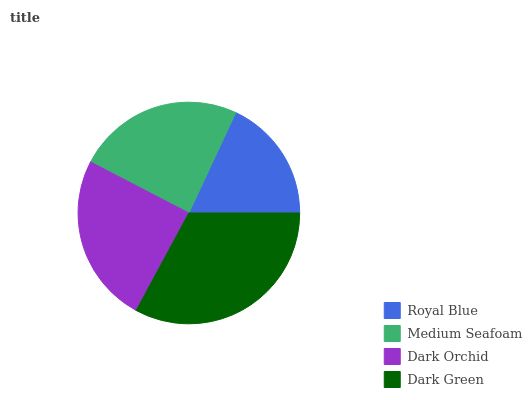Is Royal Blue the minimum?
Answer yes or no. Yes. Is Dark Green the maximum?
Answer yes or no. Yes. Is Medium Seafoam the minimum?
Answer yes or no. No. Is Medium Seafoam the maximum?
Answer yes or no. No. Is Medium Seafoam greater than Royal Blue?
Answer yes or no. Yes. Is Royal Blue less than Medium Seafoam?
Answer yes or no. Yes. Is Royal Blue greater than Medium Seafoam?
Answer yes or no. No. Is Medium Seafoam less than Royal Blue?
Answer yes or no. No. Is Dark Orchid the high median?
Answer yes or no. Yes. Is Medium Seafoam the low median?
Answer yes or no. Yes. Is Dark Green the high median?
Answer yes or no. No. Is Dark Green the low median?
Answer yes or no. No. 